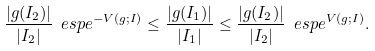<formula> <loc_0><loc_0><loc_500><loc_500>\frac { | g ( I _ { 2 } ) | } { | I _ { 2 } | } \ e s p e ^ { - V ( g ; I ) } \leq \frac { | g ( I _ { 1 } ) | } { | I _ { 1 } | } \leq \frac { | g ( I _ { 2 } ) | } { | I _ { 2 } | } \ e s p e ^ { V ( g ; I ) } .</formula> 